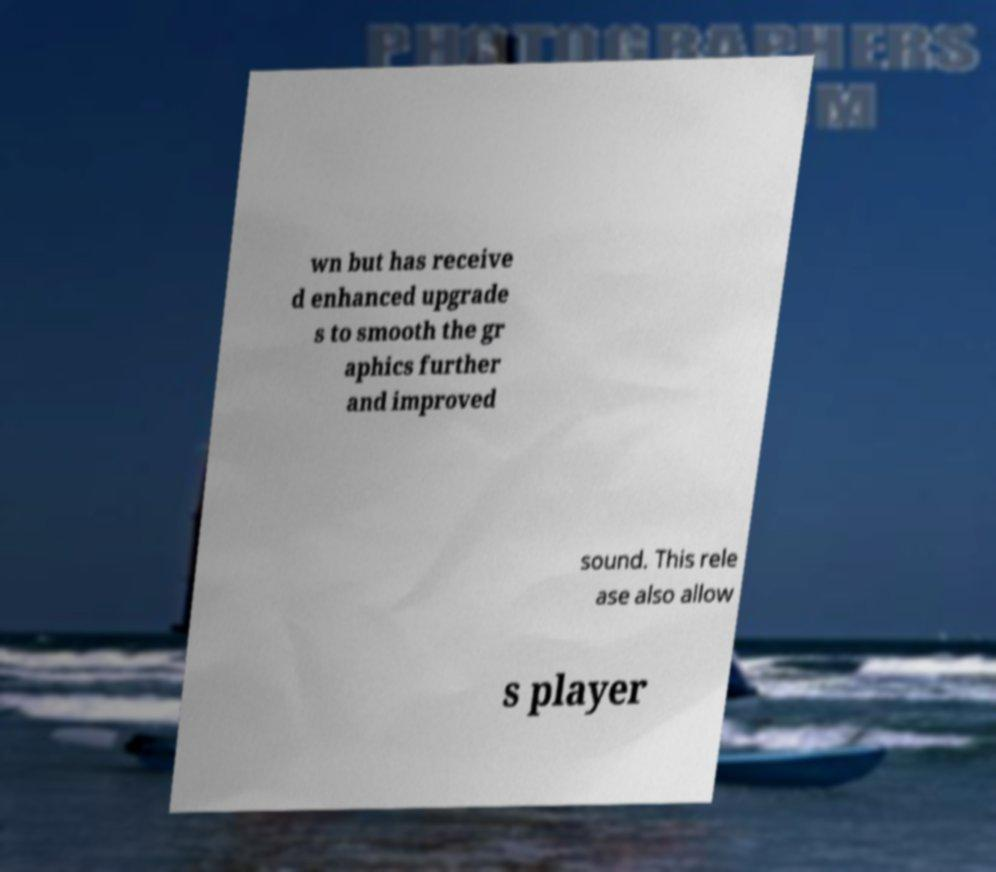Please read and relay the text visible in this image. What does it say? wn but has receive d enhanced upgrade s to smooth the gr aphics further and improved sound. This rele ase also allow s player 